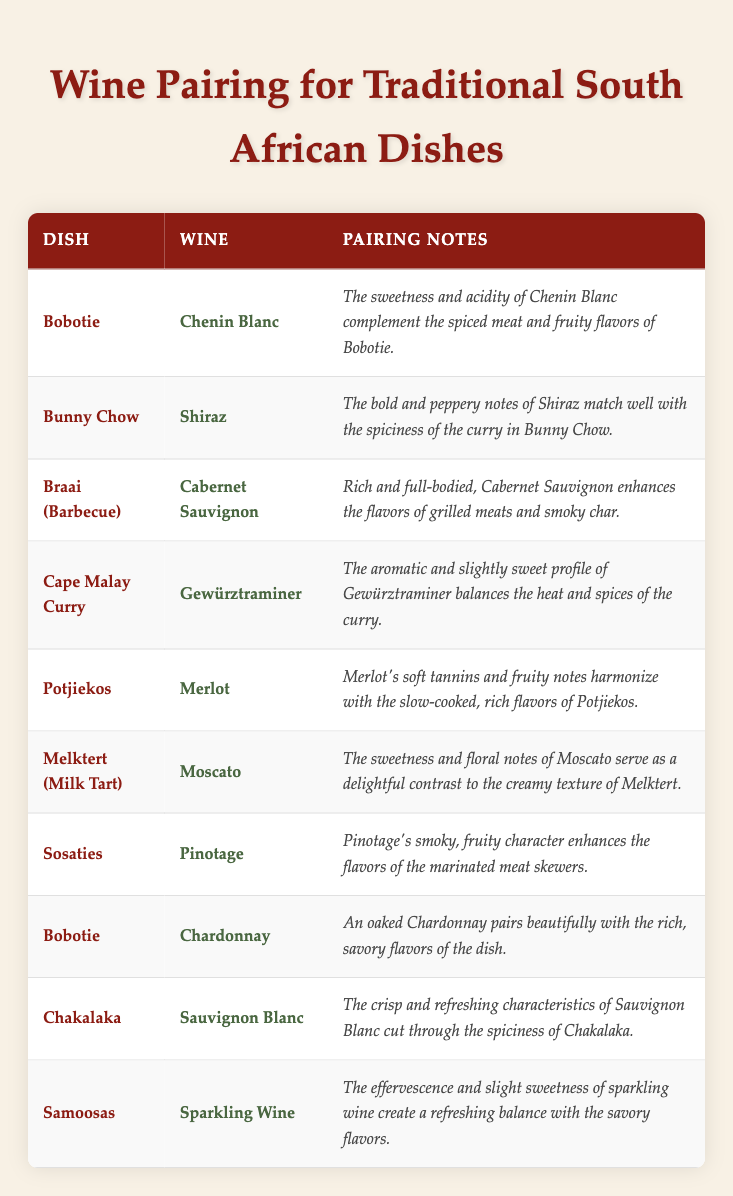What wine is recommended for Bobotie? The table lists two different wines paired with Bobotie: Chenin Blanc and Chardonnay.
Answer: Chenin Blanc, Chardonnay What pairing notes accompany the recommendation of Shiraz for Bunny Chow? The pairing notes for Shiraz state that it matches well with the spiciness of the curry in Bunny Chow due to its bold and peppery notes.
Answer: The bold and peppery notes match the spiciness of the curry Is there a wine recommendation for Melktert? Yes, the table recommends Moscato for Melktert.
Answer: Yes What wine can enhance the flavors of grilled meats during a Braai? The table indicates that Cabernet Sauvignon enhances the flavors of grilled meats.
Answer: Cabernet Sauvignon Which wines pair well with Bobotie, and how do their notes differ? Bobotie is paired with Chenin Blanc and Chardonnay. The Chenin Blanc complements the spiced meat and fruity flavors, while the Chardonnay beautifully pairs with the rich, savory flavors.
Answer: Chenin Blanc (complements spiced meat), Chardonnay (pairs with rich flavors) Which dish has the wine pairing Gewürztraminer, and what is the reason for this pairing? The dish paired with Gewürztraminer is Cape Malay Curry, and its aromatic and slightly sweet profile balances the heat and spices of the curry.
Answer: Cape Malay Curry; balances heat and spices Does any dish have two different wine recommendations? Yes, Bobotie has two different recommendations: Chenin Blanc and Chardonnay.
Answer: Yes What is the common characteristic of the wines recommended for spicy dishes? The wines for spicy dishes like Bunny Chow and Chakalaka (Shiraz and Sauvignon Blanc, respectively) have bold or crisp notes that balance and complement the spice.
Answer: Bold or crisp notes Which dish has a pairing note about balancing heat and spices? Cape Malay Curry has a pairing note about balancing heat and spices with Gewürztraminer.
Answer: Cape Malay Curry Can you list any dishes paired with Pinotage? The dish paired with Pinotage is Sosaties.
Answer: Sosaties What wine is suggested for the savory flavors of Samoosas? The wine suggested for Samoosas is Sparkling Wine, which adds a refreshing balance with the savory flavors.
Answer: Sparkling Wine 